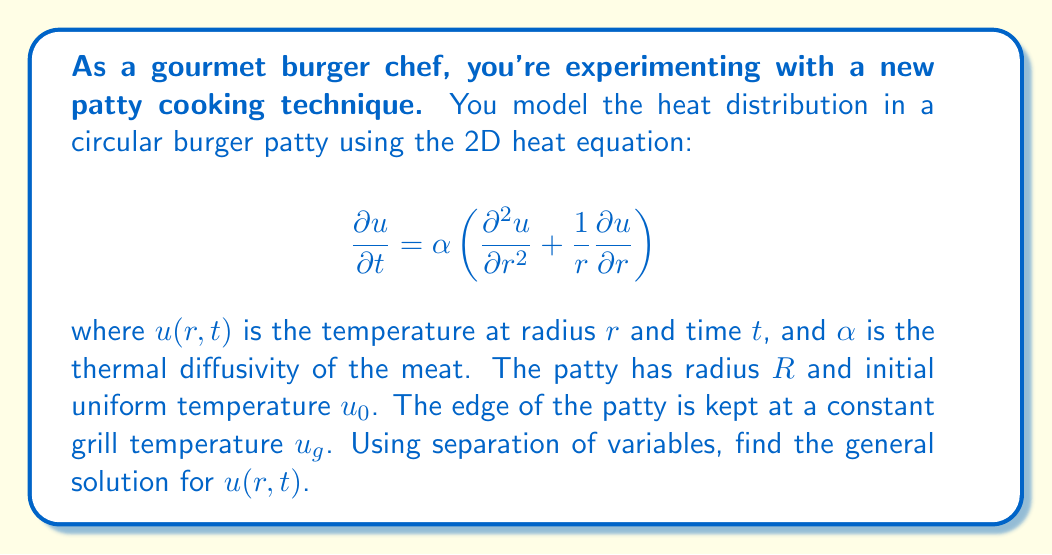Teach me how to tackle this problem. Let's solve this step-by-step:

1) We use separation of variables, assuming $u(r,t) = R(r)T(t)$.

2) Substituting into the PDE:

   $$R(r)T'(t) = \alpha \left(R''(r)T(t) + \frac{1}{r}R'(r)T(t)\right)$$

3) Dividing both sides by $\alpha R(r)T(t)$:

   $$\frac{T'(t)}{\alpha T(t)} = \frac{R''(r)}{R(r)} + \frac{1}{r}\frac{R'(r)}{R(r)} = -\lambda^2$$

   Where $-\lambda^2$ is the separation constant.

4) For the time part:
   $$T'(t) = -\alpha\lambda^2 T(t)$$
   $$T(t) = Ce^{-\alpha\lambda^2 t}$$

5) For the spatial part:
   $$r^2R''(r) + rR'(r) + \lambda^2r^2R(r) = 0$$

   This is Bessel's equation of order 0. The general solution is:

   $$R(r) = AJ_0(\lambda r) + BY_0(\lambda r)$$

   where $J_0$ and $Y_0$ are Bessel functions of the first and second kind.

6) Since $Y_0$ is singular at $r=0$, and we need our solution to be finite at the center of the patty, $B$ must be 0.

7) The boundary condition $u(R,t) = u_g$ implies:

   $$AJ_0(\lambda R) = 0$$

   This means $\lambda R$ must be a zero of $J_0$. Let's denote the nth zero of $J_0$ as $\lambda_n R$.

8) The general solution is thus:

   $$u(r,t) = u_g + \sum_{n=1}^{\infty} C_n J_0(\lambda_n r)e^{-\alpha\lambda_n^2 t}$$

   where $C_n$ are constants determined by the initial condition.
Answer: $$u(r,t) = u_g + \sum_{n=1}^{\infty} C_n J_0(\lambda_n r)e^{-\alpha\lambda_n^2 t}$$ 